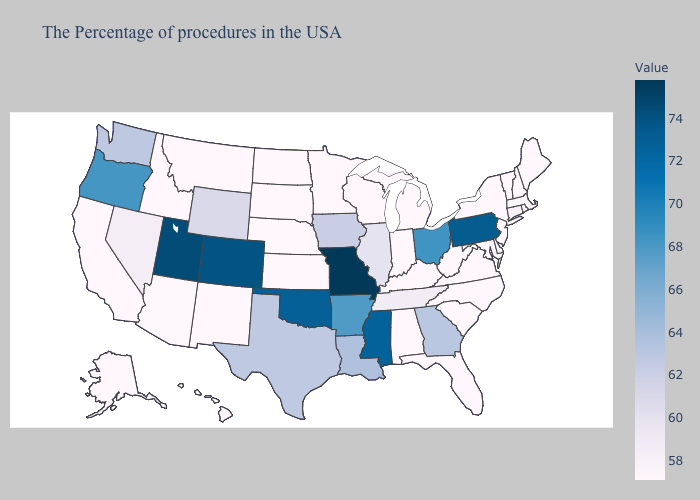Does Rhode Island have a higher value than Utah?
Be succinct. No. Among the states that border Indiana , which have the highest value?
Be succinct. Ohio. 